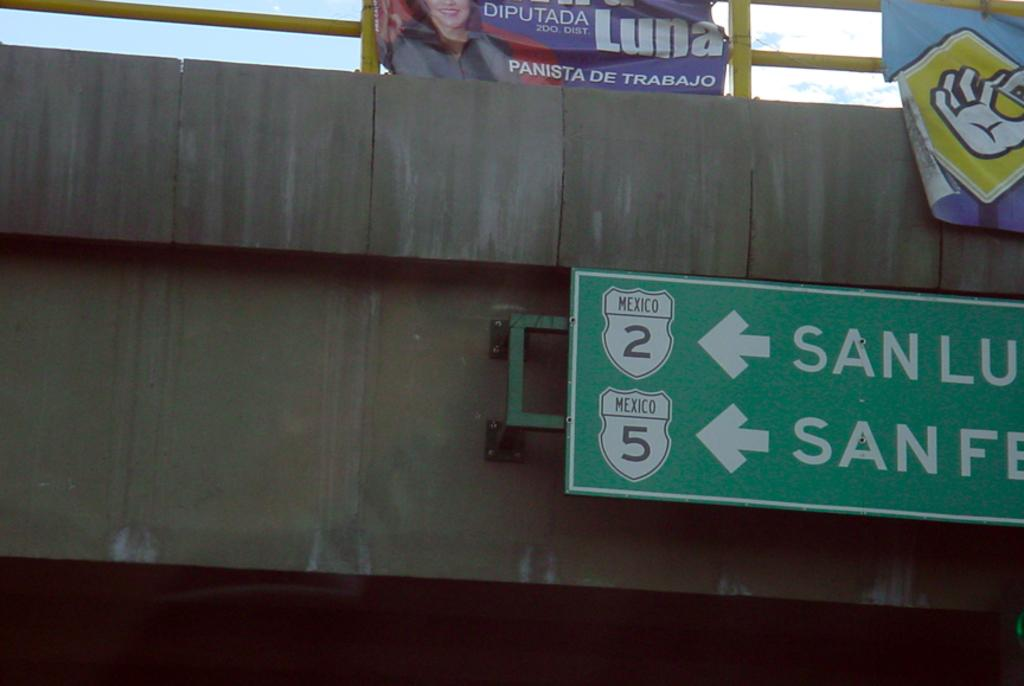<image>
Share a concise interpretation of the image provided. A green highway sign pointing to Mexico's Highway 2 and Highway 5 